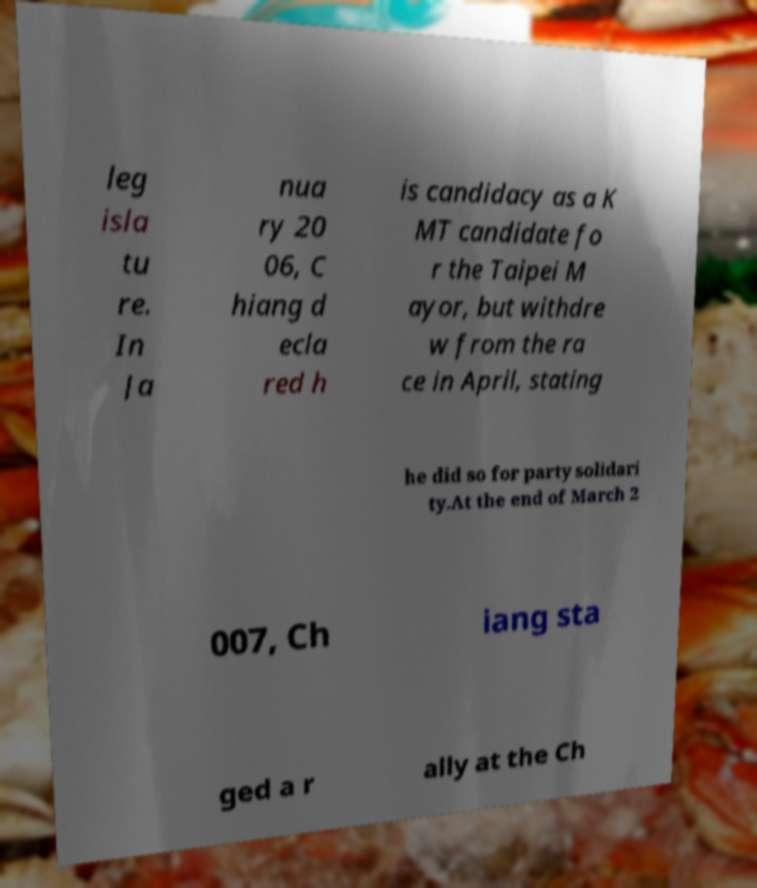Could you extract and type out the text from this image? leg isla tu re. In Ja nua ry 20 06, C hiang d ecla red h is candidacy as a K MT candidate fo r the Taipei M ayor, but withdre w from the ra ce in April, stating he did so for party solidari ty.At the end of March 2 007, Ch iang sta ged a r ally at the Ch 